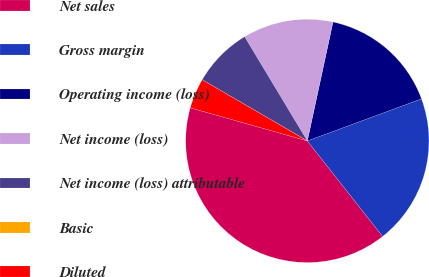<chart> <loc_0><loc_0><loc_500><loc_500><pie_chart><fcel>Net sales<fcel>Gross margin<fcel>Operating income (loss)<fcel>Net income (loss)<fcel>Net income (loss) attributable<fcel>Basic<fcel>Diluted<nl><fcel>40.0%<fcel>20.0%<fcel>16.0%<fcel>12.0%<fcel>8.0%<fcel>0.0%<fcel>4.0%<nl></chart> 